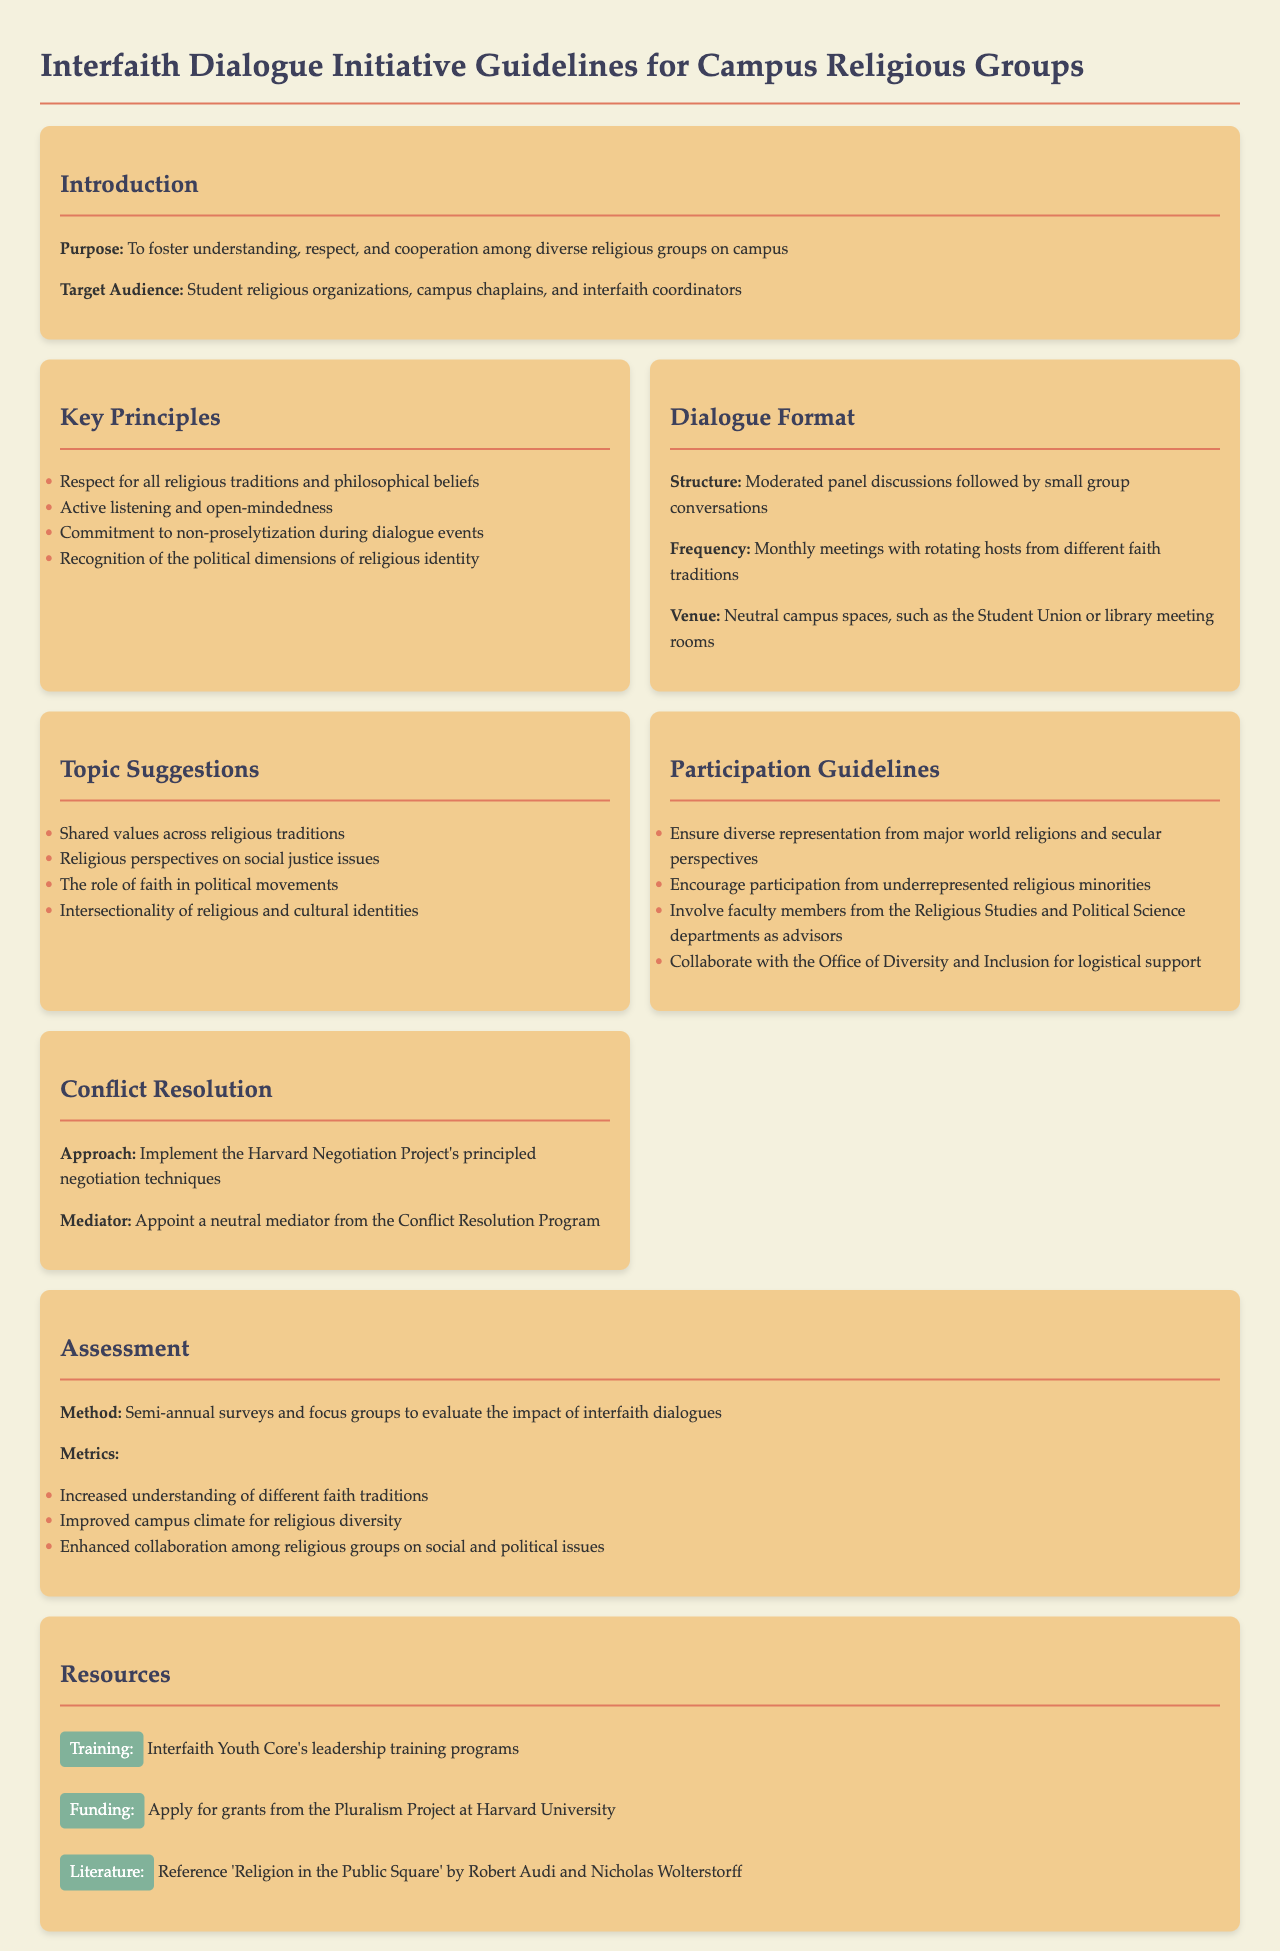What is the purpose of the guidelines? The purpose is to foster understanding, respect, and cooperation among diverse religious groups on campus.
Answer: To foster understanding, respect, and cooperation among diverse religious groups on campus Who is the target audience for these guidelines? The target audience includes student religious organizations, campus chaplains, and interfaith coordinators.
Answer: Student religious organizations, campus chaplains, and interfaith coordinators What is the structure of the dialogue format? The structure is described as moderated panel discussions followed by small group conversations.
Answer: Moderated panel discussions followed by small group conversations How often are the dialogue meetings held? The meetings are held monthly with rotating hosts from different faith traditions.
Answer: Monthly meetings with rotating hosts from different faith traditions What approach is suggested for conflict resolution? The document suggests implementing the Harvard Negotiation Project's principled negotiation techniques.
Answer: Implement the Harvard Negotiation Project's principled negotiation techniques What is one metric for assessing the impact of interfaith dialogues? One metric mentioned is increased understanding of different faith traditions.
Answer: Increased understanding of different faith traditions What is a resource for training mentioned in the document? The Interfaith Youth Core's leadership training programs are identified as a training resource.
Answer: Interfaith Youth Core's leadership training programs 